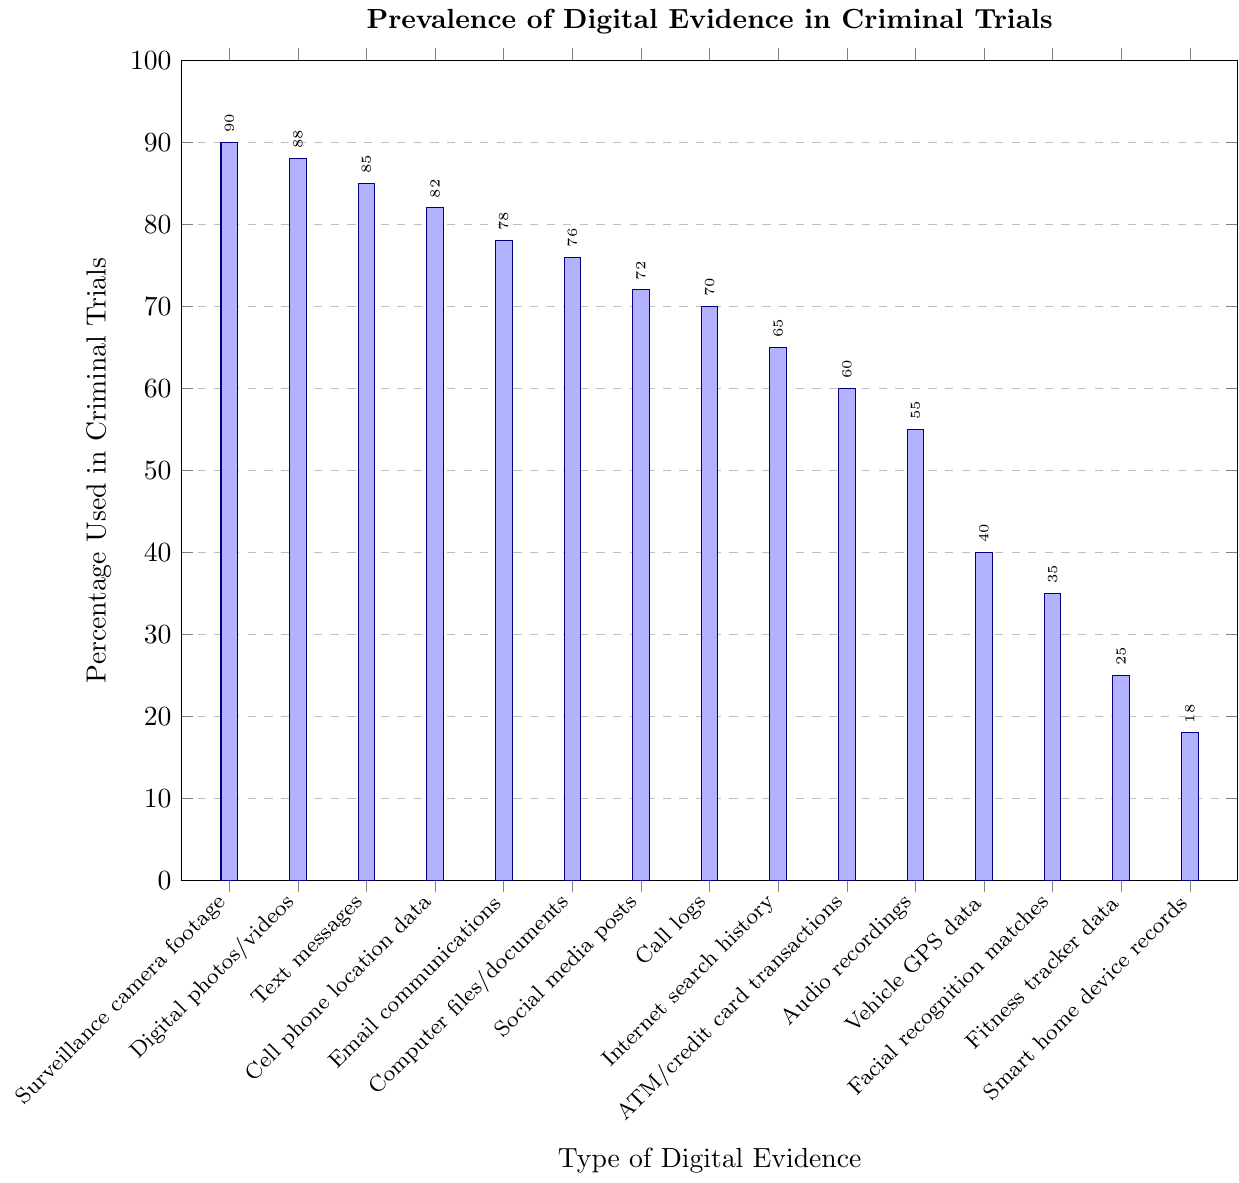Which type of digital evidence is used most frequently in criminal trials? The bar that is tallest and reaches the highest percentage represents the type of digital evidence used most frequently. "Surveillance camera footage" is the tallest bar at 90%.
Answer: Surveillance camera footage What is the combined percentage use of Email communications and Text messages? Refer to the heights of the bars for Email communications (78%) and Text messages (85%). Adding these percentages together: 78% + 85% = 163%.
Answer: 163% Which two types of digital evidence have the lowest usage in criminal trials? Identify the shortest two bars in the chart. The shortest bars correspond to "Smart home device records" (18%) and "Fitness tracker data" (25%).
Answer: Smart home device records, Fitness tracker data Is the percentage of Cell phone location data usage greater or less than that of Digital photos/videos? Compare the heights of the Cell phone location data bar (82%) and the Digital photos/videos bar (88%).
Answer: Less What is the average percentage use of the top three most frequently used types of digital evidence? Identify the top three bars: Surveillance camera footage (90%), Digital photos/videos (88%), and Text messages (85%). Calculate their average: (90% + 88% + 85%) / 3 = 87.67%.
Answer: 87.67% What is the median percentage use of all types of digital evidence listed? Sort the percentages in ascending order and find the middle value. Sorted values: 18%, 25%, 35%, 40%, 55%, 60%, 65%, 70%, 72%, 76%, 78%, 82%, 85%, 88%, 90%. The middle value is the 8th value (70%).
Answer: 70% Which type of digital evidence has a usage percentage closest to 50%? Find the bar whose height (percentage) is closest to 50%. "Audio recordings" has a usage percentage of 55%, which is the closest to 50%.
Answer: Audio recordings How much higher is the usage percentage of Call logs compared to Vehicle GPS data? Examine the heights of the Call logs bar (70%) and the Vehicle GPS data bar (40%). The difference is 70% - 40% = 30%.
Answer: 30% What is the difference in usage percentage between the most frequently used and least frequently used digital evidence? Find the values of the highest (Surveillance camera footage, 90%) and lowest (Smart home device records, 18%) bars, then calculate their difference: 90% - 18% = 72%.
Answer: 72% Which types of digital evidence fall within the 60% to 80% usage range? Identify the bars whose heights fall between 60% and 80%. These are "Email communications" (78%), "Computer files/documents" (76%), "Social media posts" (72%), "Call logs" (70%), and "Internet search history" (65%).
Answer: Email communications, Computer files/documents, Social media posts, Call logs, Internet search history 